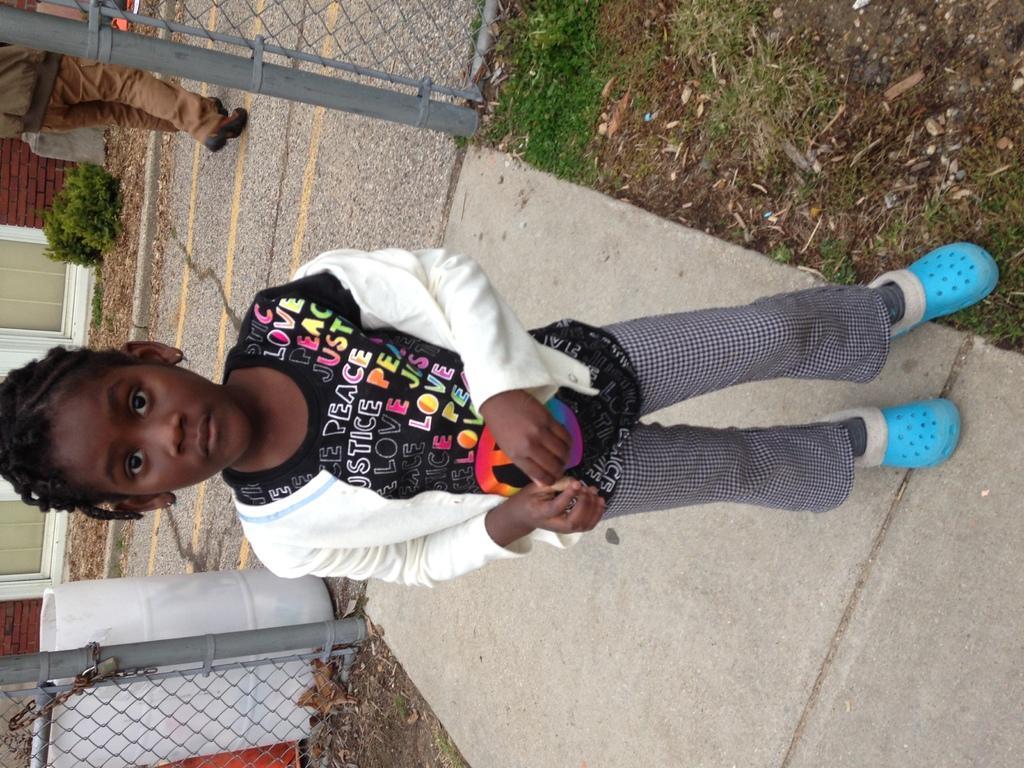How would you summarize this image in a sentence or two? In the image we can see a girl standing, wearing clothes and shoes. This is a footpath, fence, soil, grass, plant, container and a brick wall. Behind her there is a person walking. 